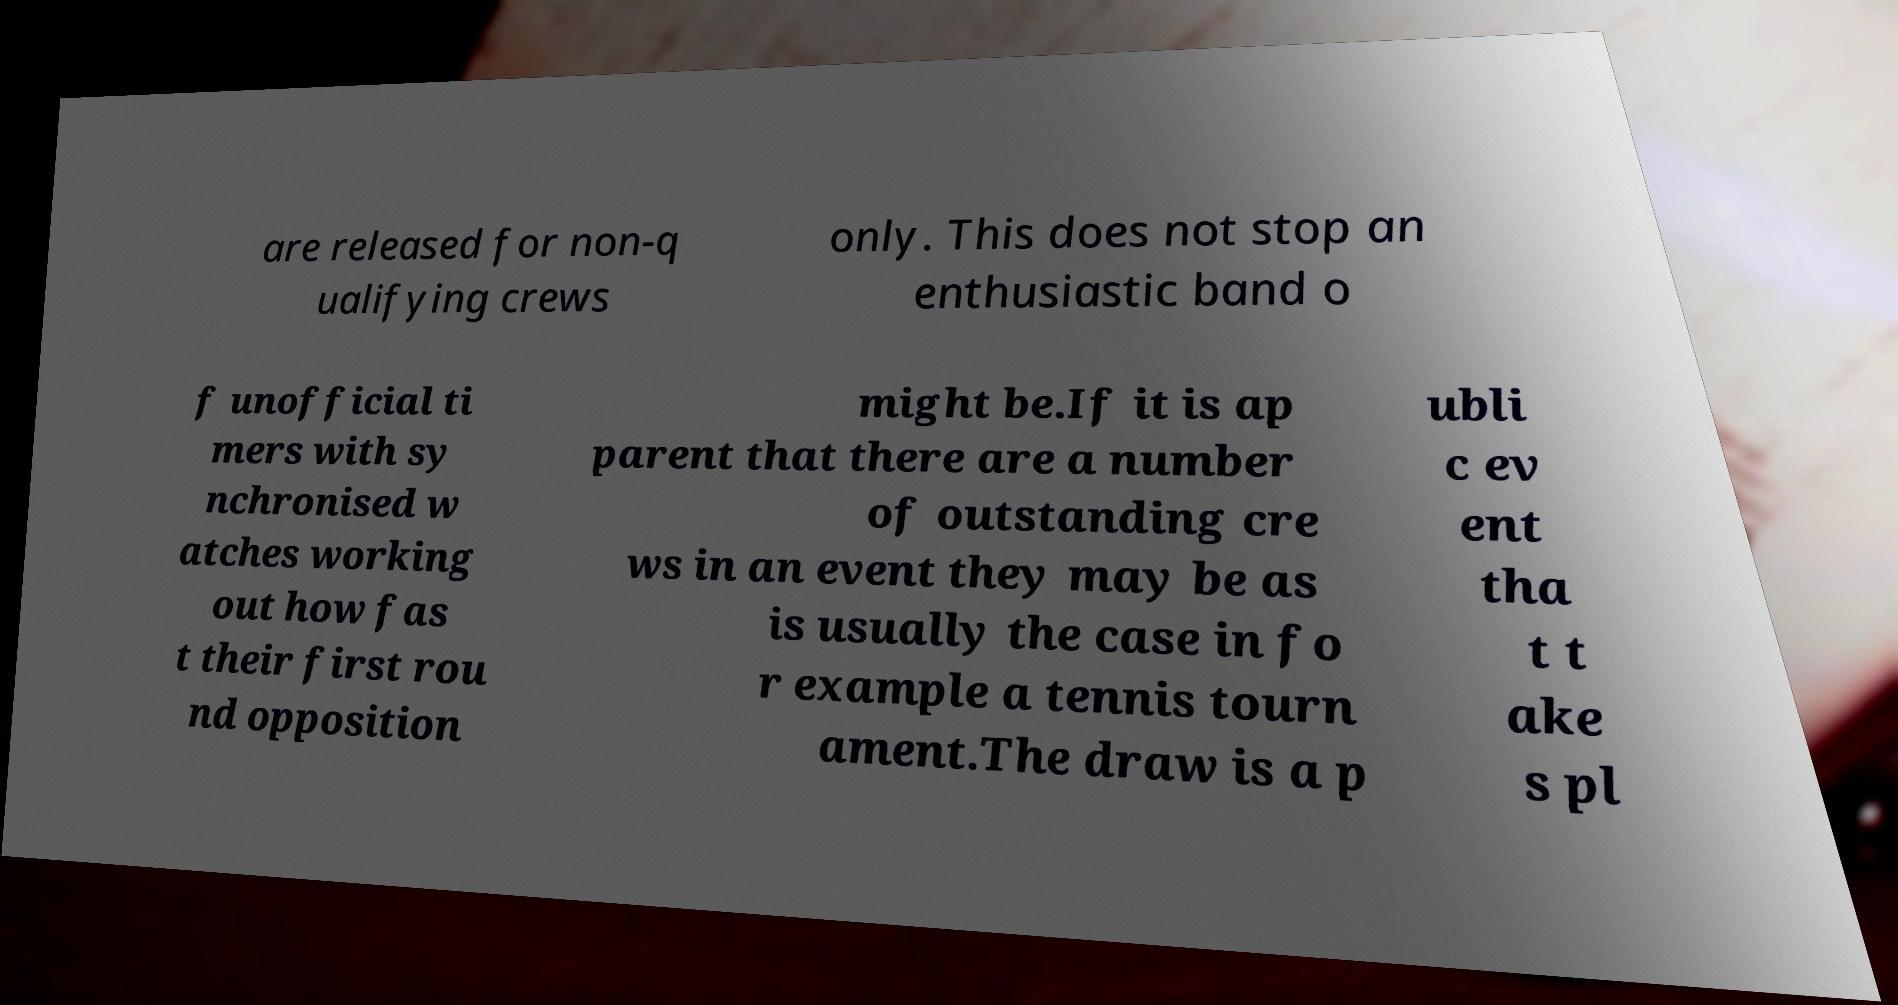Could you assist in decoding the text presented in this image and type it out clearly? are released for non-q ualifying crews only. This does not stop an enthusiastic band o f unofficial ti mers with sy nchronised w atches working out how fas t their first rou nd opposition might be.If it is ap parent that there are a number of outstanding cre ws in an event they may be as is usually the case in fo r example a tennis tourn ament.The draw is a p ubli c ev ent tha t t ake s pl 